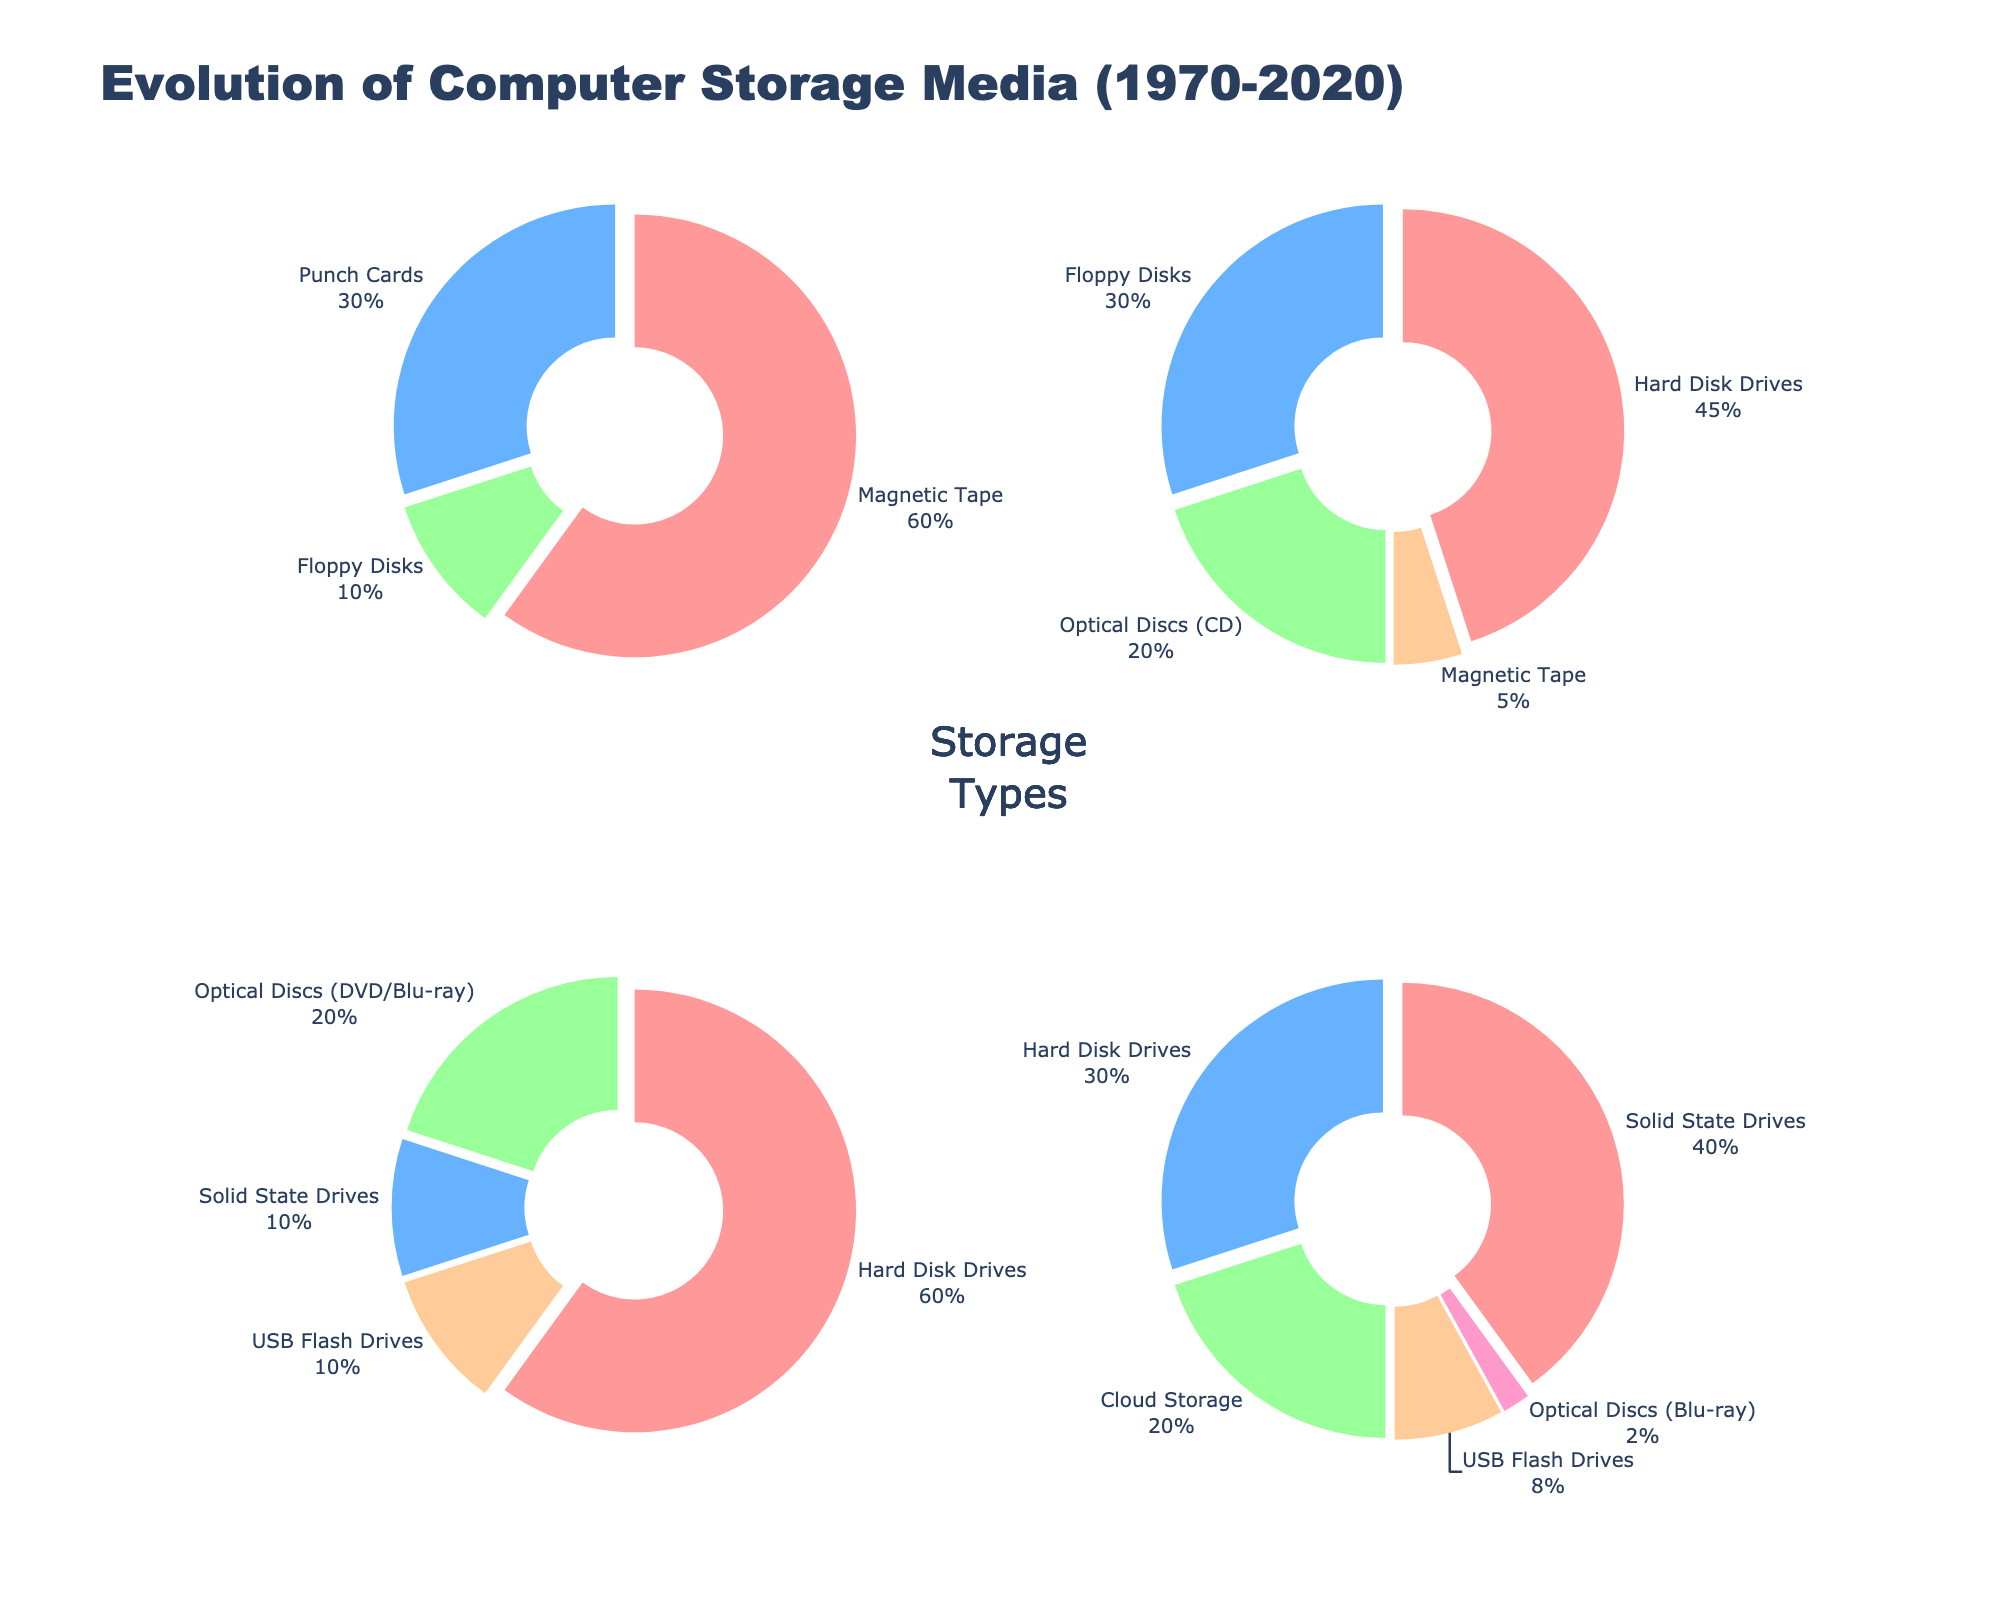Which year had the highest percentage of punch cards usage? Look at the pie chart for each year. In 1970, punch cards account for 30%, and it's the only year showing any usage of punch cards.
Answer: 1970 What percentage of storage media in 2020 was optical discs (Blu-ray)? Inspect the pie chart for the year 2020. Blu-ray optical discs account for 2% of storage media.
Answer: 2% In which year did hard disk drives have the highest percentage usage? Compare the proportions of hard disk drives across all the years. In 2010, hard disk drives account for 60% of the storage media, which is the highest.
Answer: 2010 What is the combined percentage of USB flash drives in 2010 and 2020? Look at the pie charts for 2010 and 2020. USB flash drives account for 10% in 2010 and 8% in 2020. The combined percentage is 10% + 8% = 18%.
Answer: 18% Which media type had the largest percentage drop from 1970 to 1990? Compare the percentages of each media type in 1970 and 1990. Magnetic tape decreases from 60% in 1970 to 5% in 1990, which is a drop of 55%.
Answer: Magnetic Tape How does the percentage of solid-state drives in 2020 compare to its percentage in 2010? Compare the percentages of SSDs between 2010 and 2020. SSDs account for 10% in 2010 and 40% in 2020, showing an increase.
Answer: Increase Which year introduced the highest number of new storage media types compared to the previous years? Identify the media types and their first appearance in each year. 2010 introduced SSDs and USB flash drives, while other years introduced fewer new types.
Answer: 2010 What's the average percentage share of optical discs (CD/DVD/Blu-ray) across all given years? Compute the average as follows: (0% in 1970 + 20% in 1990 + 20% in 2010 + 2% in 2020) / 4 = 10.5%.
Answer: 10.5% Which year had the lowest diversity of storage media types and what are they? Identify the variety of media types for each year. In 1970, there are only three media types: magnetic tape, punch cards, and floppy disks, which is the least diverse.
Answer: 1970; magnetic tape, punch cards, floppy disks 